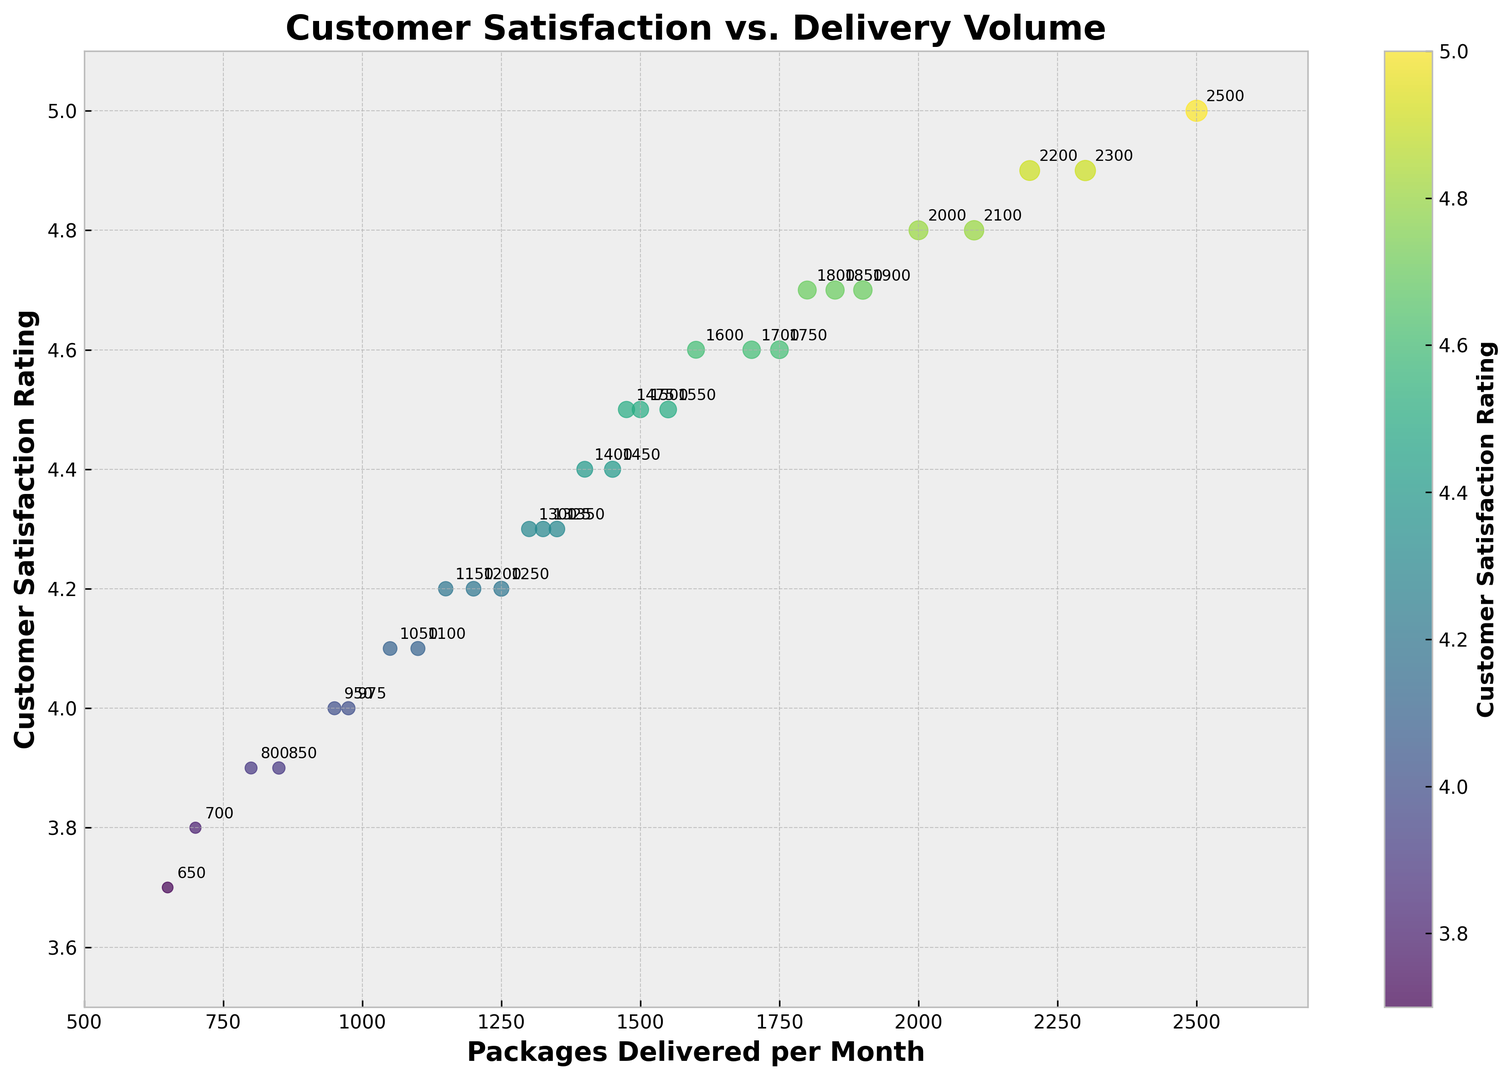What is the highest customer satisfaction rating shown in the plot? Identify the point with the maximum y-value on the scatter plot, which represents the highest customer satisfaction rating.
Answer: 5.0 What is the lowest number of packages delivered per month in the plot? Locate the point with the minimum x-value on the scatter plot, indicating the lowest number of packages delivered per month.
Answer: 650 What is the average customer satisfaction rating for deliveries above 1500 packages per month? First, identify the points with x-values above 1500. These ratings are 4.7, 4.6, 4.8, 4.9, 5.0, 4.7, and 4.8. The sum is 33.5. The average is 33.5 divided by 7.
Answer: 4.79 Which data point has the highest ratio of customer satisfaction rating to packages delivered per month? Calculate the ratio for each point (rating/deliveries). Find the maximum value among these ratios.
Answer: 5.0/2500 = 0.002 Is there a correlation between the number of packages delivered per month and customer satisfaction rating? Visually inspect the scatter plot for any trend or pattern. The plot shows a positive correlation where higher deliveries often correspond to higher satisfaction ratings.
Answer: Yes How many data points have customer satisfaction ratings above 4.5? Count the points with y-values greater than 4.5. These points include satisfaction ratings of 4.6, 4.7, 4.8, 5.0, 4.6, 4.7, 4.8, and 4.9.
Answer: 8 Do higher customer satisfaction ratings generally correspond to larger points in the plot? Larger points indicate higher packages delivered. Check if points with higher y-values (ratings) have larger sizes. Yes, higher ratings correspond to larger points.
Answer: Yes How many packages are delivered for the point with a customer satisfaction rating of 4.0? Locate the point with a y-value of 4.0 and read off the corresponding x-value.
Answer: 950 Which two data points have the closest customer satisfaction ratings but different package delivery amounts? Compare y-values of adjacent points: (4.8, 2000) and (4.8, 2100) have identical ratings. (4.4, 1400) and (4.4, 1450) are very close. Compare visually and confirm.
Answer: (4.4, 1400) and (4.4, 1450) Does the color of the points have any significance related to customer satisfaction rating? The color bar indicates that the color represents the customer satisfaction rating. Darker colors represent lower ratings, and lighter colors indicate higher ratings.
Answer: Yes 